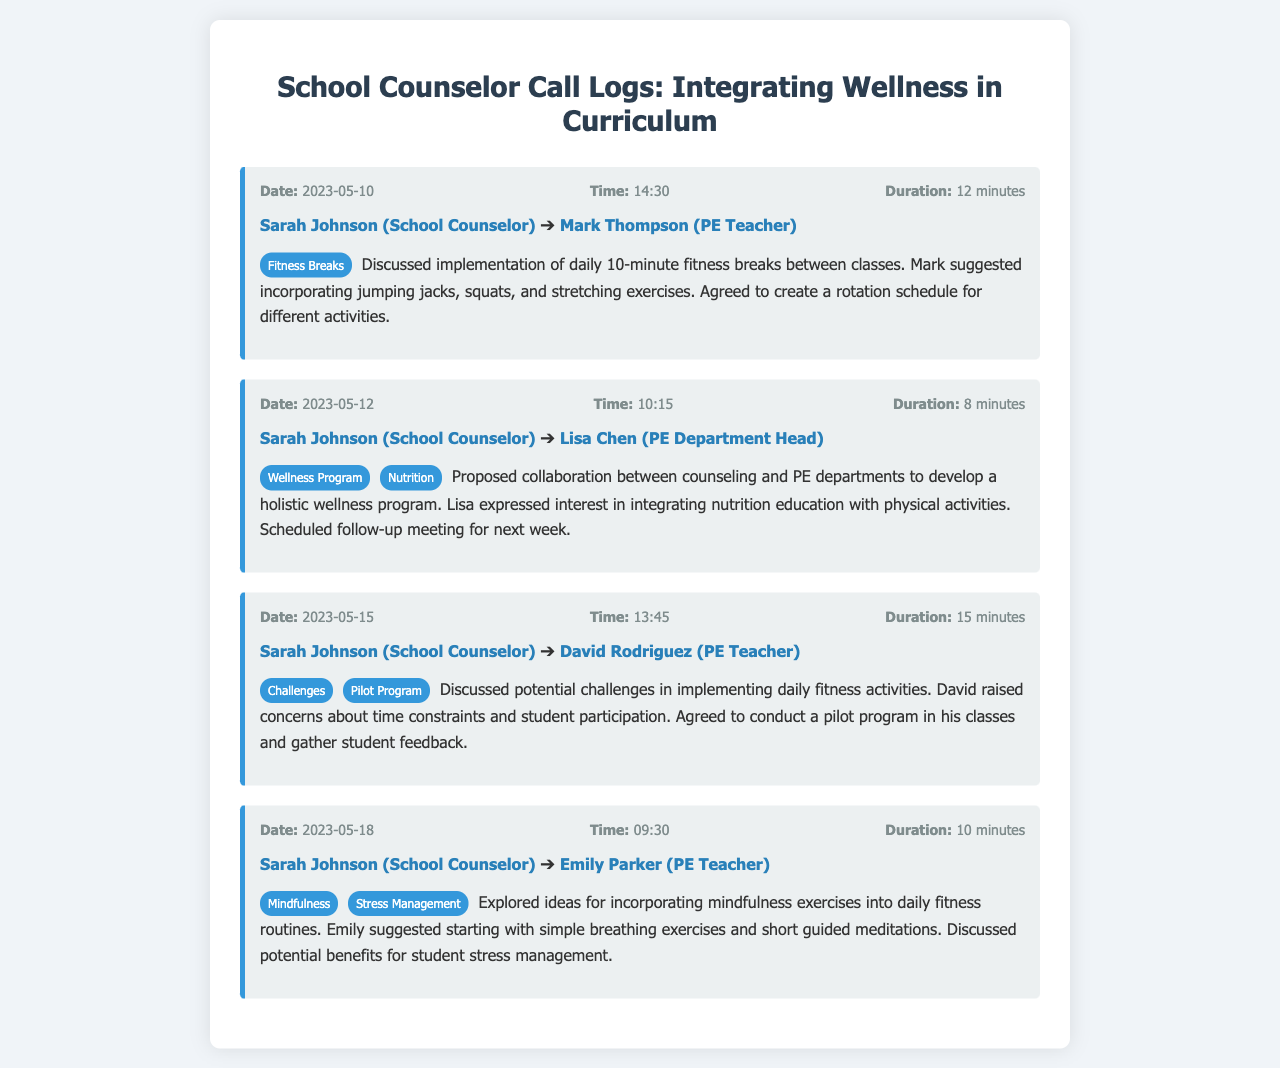what is the date of the first call? The first call occurred on May 10, 2023.
Answer: May 10, 2023 who is the recipient of the call on May 12? The recipient of the call on May 12 is Lisa Chen.
Answer: Lisa Chen what was discussed in the call with David Rodriguez? The call with David Rodriguez discussed potential challenges in implementing daily fitness activities.
Answer: challenges in implementing daily fitness activities how long was the call with Emily Parker? The call with Emily Parker lasted 10 minutes.
Answer: 10 minutes what type of program was proposed by Sarah Johnson on May 12? Sarah Johnson proposed a holistic wellness program.
Answer: holistic wellness program what exercise activity did Mark suggest for fitness breaks? Mark suggested incorporating jumping jacks for fitness breaks.
Answer: jumping jacks who expressed interest in integrating nutrition education? Lisa expressed interest in integrating nutrition education with physical activities.
Answer: Lisa what mindfulness exercises were suggested by Emily? Emily suggested starting with simple breathing exercises.
Answer: simple breathing exercises what was the duration of the call with Mark Thompson? The duration of the call with Mark Thompson was 12 minutes.
Answer: 12 minutes 